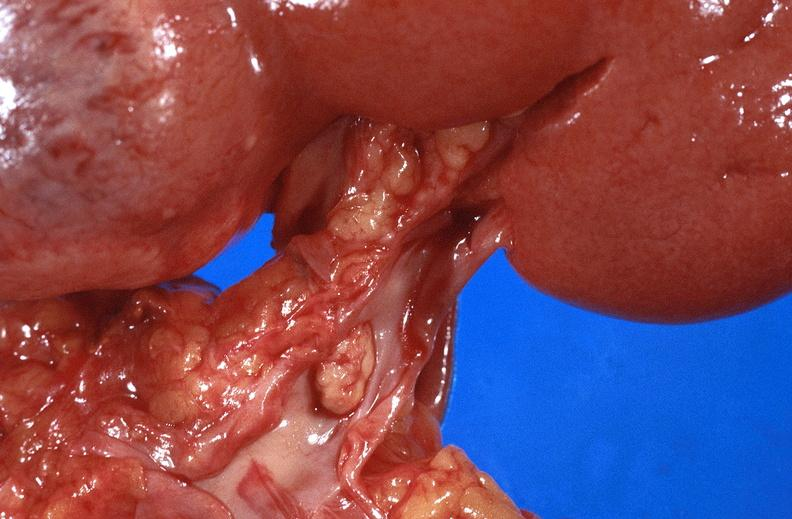does this image show renal cell carcinoma with extension into vena cava?
Answer the question using a single word or phrase. Yes 